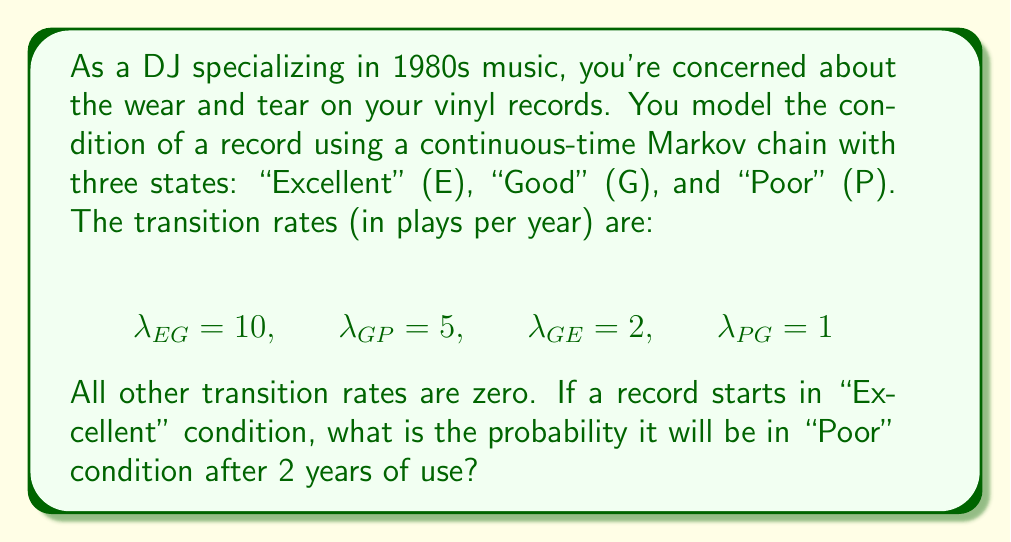Solve this math problem. To solve this problem, we need to use the continuous-time Markov chain transition probability matrix. Let's approach this step-by-step:

1) First, we need to set up the transition rate matrix Q:

   $$Q = \begin{bmatrix}
   -10 & 10 & 0 \\
   2 & -7 & 5 \\
   0 & 1 & -1
   \end{bmatrix}$$

2) The transition probability matrix after time t is given by:

   $$P(t) = e^{Qt}$$

3) We need to calculate $e^{2Q}$ since we're interested in the probability after 2 years.

4) To compute this matrix exponential, we can use the eigendecomposition method:

   $$e^{2Q} = S e^{2D} S^{-1}$$

   where D is a diagonal matrix of eigenvalues and S is a matrix of eigenvectors.

5) Calculating the eigenvalues and eigenvectors (which is typically done using software):

   Eigenvalues: $\lambda_1 = 0$, $\lambda_2 \approx -3.830$, $\lambda_3 \approx -14.170$

6) The resulting transition probability matrix after 2 years is approximately:

   $$P(2) \approx \begin{bmatrix}
   0.1353 & 0.7025 & 0.1622 \\
   0.1353 & 0.7025 & 0.1622 \\
   0.1353 & 0.7025 & 0.1622
   \end{bmatrix}$$

7) The probability of being in the "Poor" state after starting in the "Excellent" state is given by the element in the first row, third column of this matrix.
Answer: 0.1622 (or approximately 16.22%) 